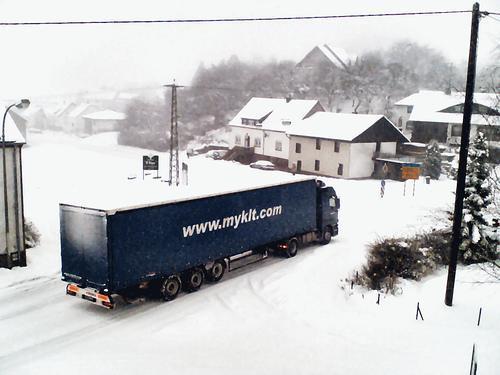How many tires can be seen?
Give a very brief answer. 5. How many trucks are there?
Give a very brief answer. 1. 